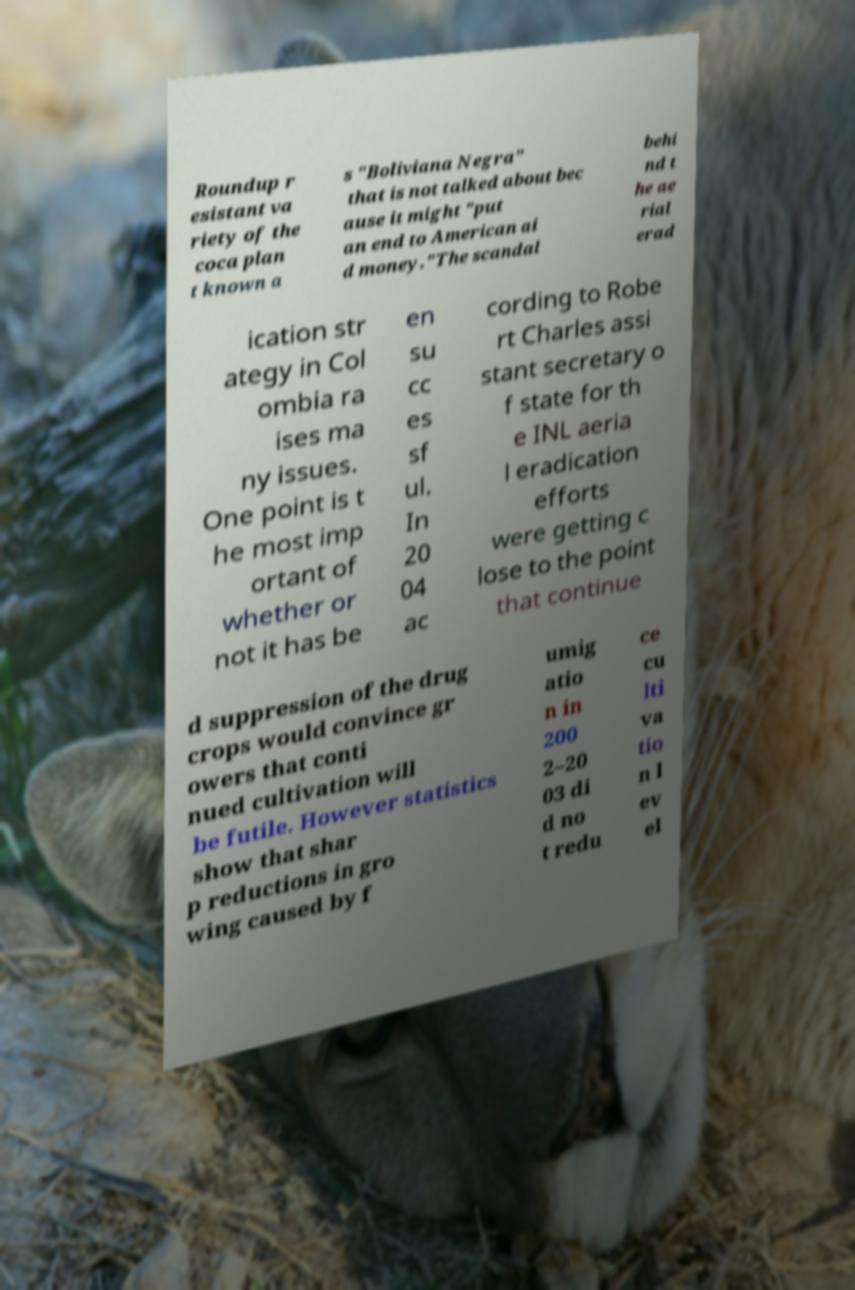I need the written content from this picture converted into text. Can you do that? Roundup r esistant va riety of the coca plan t known a s "Boliviana Negra" that is not talked about bec ause it might "put an end to American ai d money."The scandal behi nd t he ae rial erad ication str ategy in Col ombia ra ises ma ny issues. One point is t he most imp ortant of whether or not it has be en su cc es sf ul. In 20 04 ac cording to Robe rt Charles assi stant secretary o f state for th e INL aeria l eradication efforts were getting c lose to the point that continue d suppression of the drug crops would convince gr owers that conti nued cultivation will be futile. However statistics show that shar p reductions in gro wing caused by f umig atio n in 200 2–20 03 di d no t redu ce cu lti va tio n l ev el 